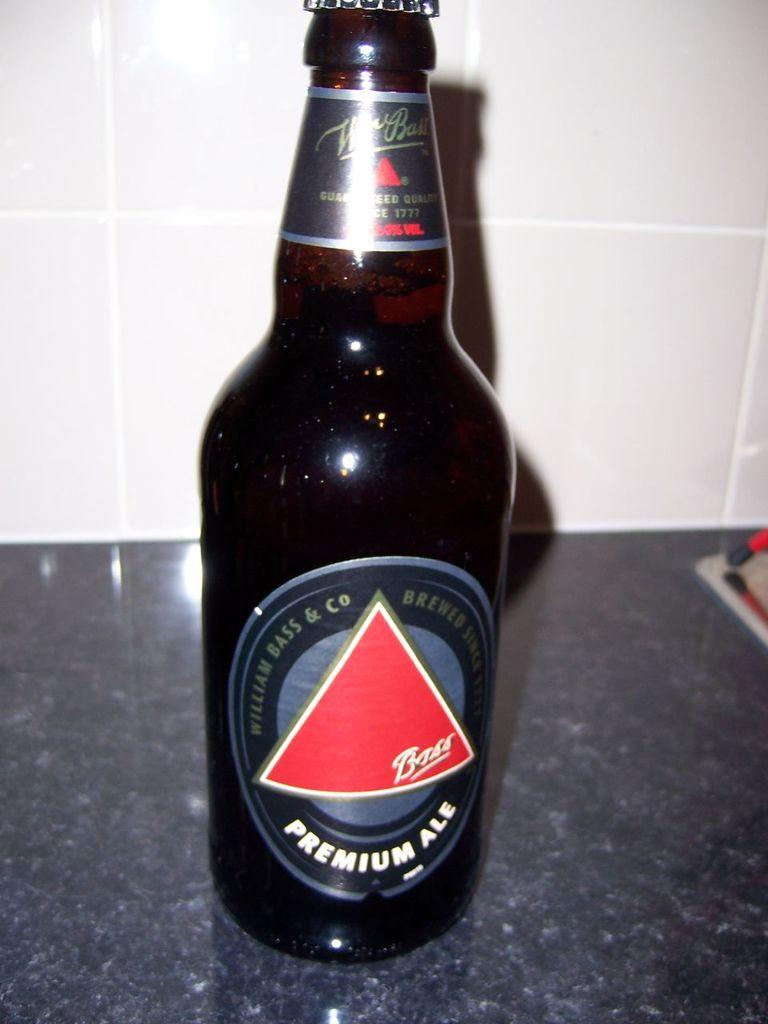What type of beer is this?
Your answer should be very brief. Premium ale. 